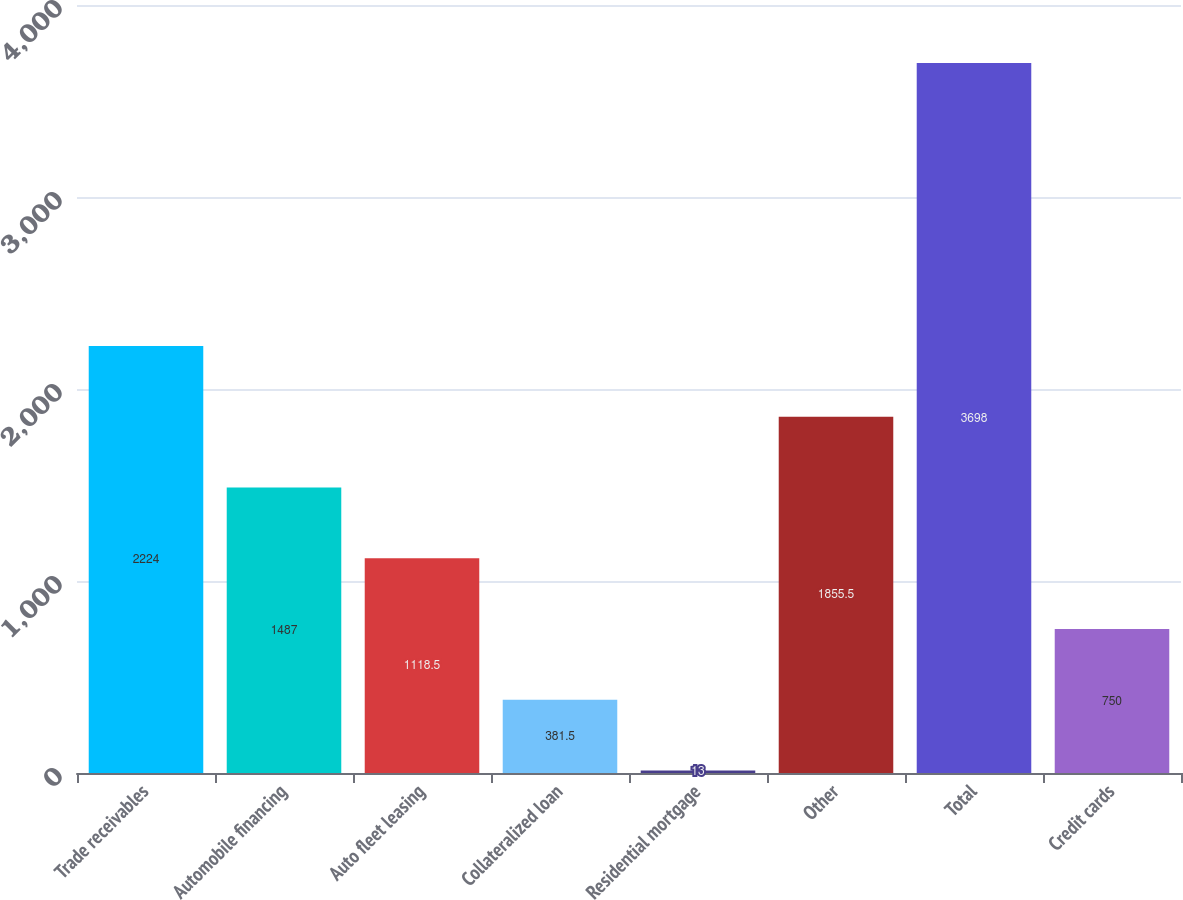<chart> <loc_0><loc_0><loc_500><loc_500><bar_chart><fcel>Trade receivables<fcel>Automobile financing<fcel>Auto fleet leasing<fcel>Collateralized loan<fcel>Residential mortgage<fcel>Other<fcel>Total<fcel>Credit cards<nl><fcel>2224<fcel>1487<fcel>1118.5<fcel>381.5<fcel>13<fcel>1855.5<fcel>3698<fcel>750<nl></chart> 